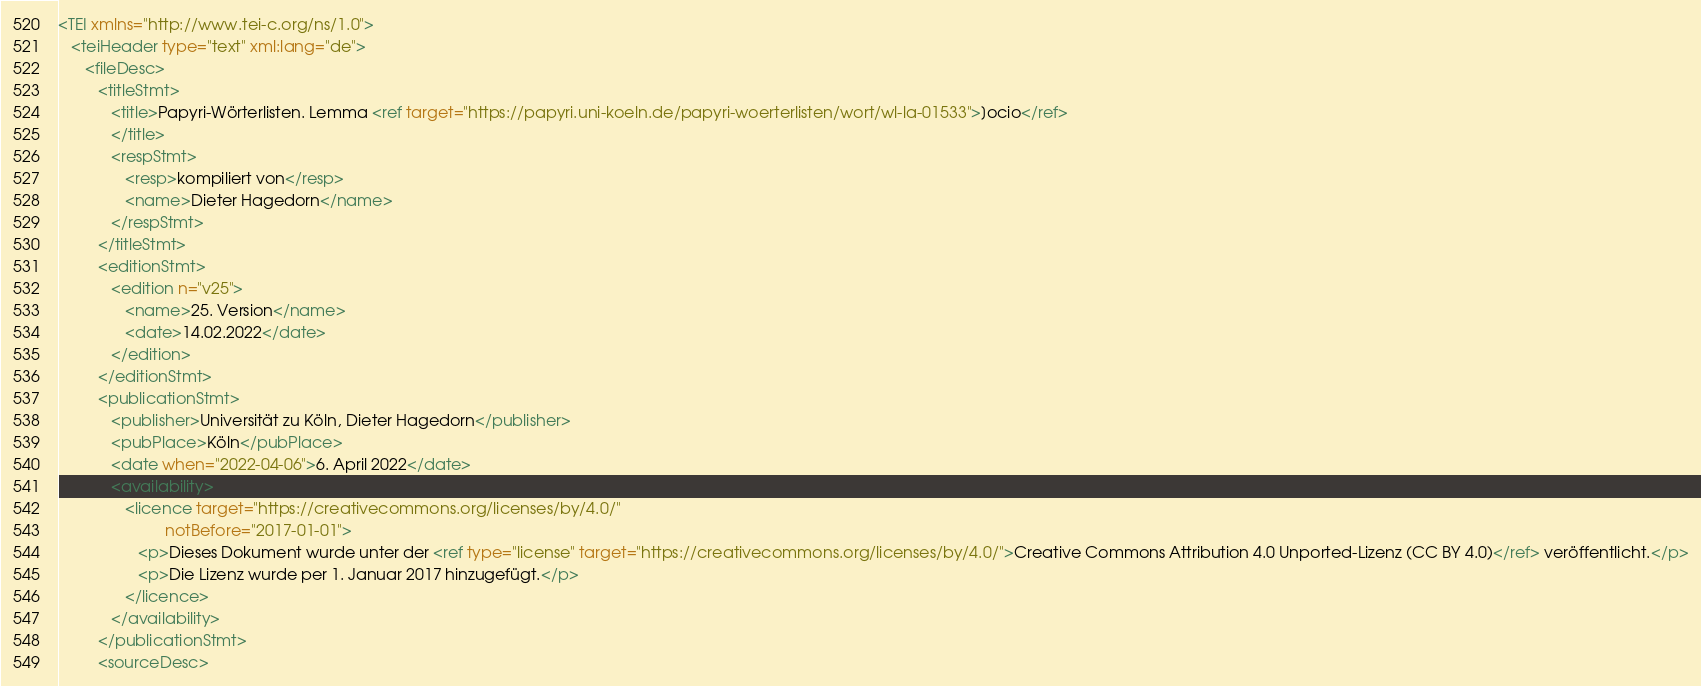<code> <loc_0><loc_0><loc_500><loc_500><_XML_><TEI xmlns="http://www.tei-c.org/ns/1.0">
   <teiHeader type="text" xml:lang="de">
      <fileDesc>
         <titleStmt>
            <title>Papyri-Wörterlisten. Lemma <ref target="https://papyri.uni-koeln.de/papyri-woerterlisten/wort/wl-la-01533">]ocio</ref>
            </title>
            <respStmt>
               <resp>kompiliert von</resp>
               <name>Dieter Hagedorn</name>
            </respStmt>
         </titleStmt>
         <editionStmt>
            <edition n="v25">
               <name>25. Version</name>
               <date>14.02.2022</date>
            </edition>
         </editionStmt>
         <publicationStmt>
            <publisher>Universität zu Köln, Dieter Hagedorn</publisher>
            <pubPlace>Köln</pubPlace>
            <date when="2022-04-06">6. April 2022</date>
            <availability>
               <licence target="https://creativecommons.org/licenses/by/4.0/"
                        notBefore="2017-01-01">
                  <p>Dieses Dokument wurde unter der <ref type="license" target="https://creativecommons.org/licenses/by/4.0/">Creative Commons Attribution 4.0 Unported-Lizenz (CC BY 4.0)</ref> veröffentlicht.</p>
                  <p>Die Lizenz wurde per 1. Januar 2017 hinzugefügt.</p>
               </licence>
            </availability>
         </publicationStmt>
         <sourceDesc></code> 